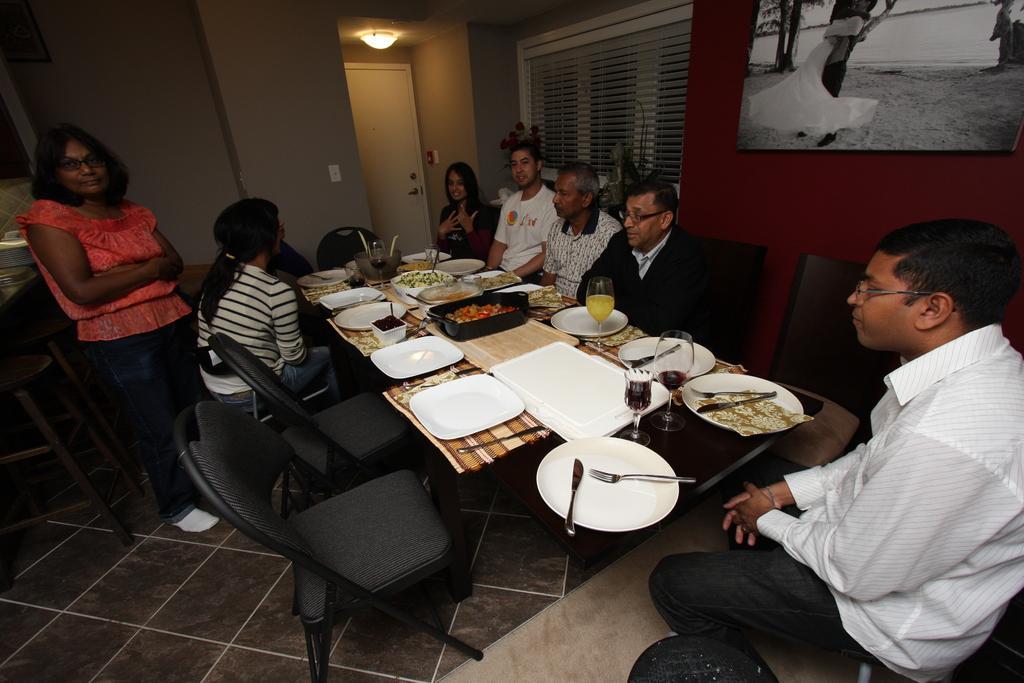Please provide a concise description of this image. This image is taken inside a room. There are few people in this room sitting on the chairs. There are three women and four men In this image. In the left side of the image a woman is standing on the floor. In the right side of the image a man is sitting on the chair. In the middle of this image there is a table with many things and food item on it. In the bottom of the image there is a floor. In the background there is a wall with window blind, window and a picture frame on it. 